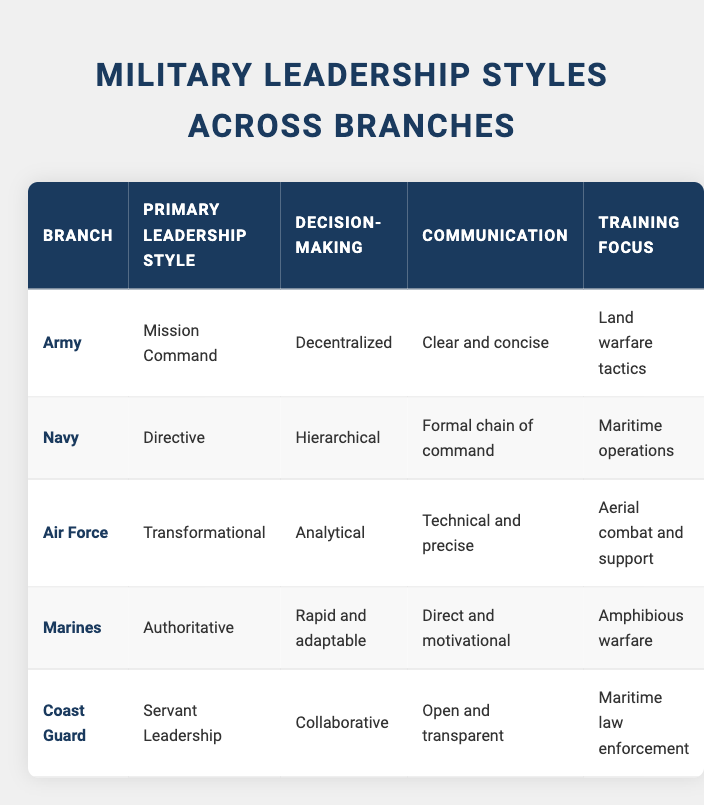What is the primary leadership style of the Marines? The table lists the primary leadership style of the Marines in the corresponding row. It shows that the Marines adopt an "Authoritative" leadership style.
Answer: Authoritative Which branch has a training focus on maritime law enforcement? By reviewing the table, we can identify that the Coast Guard is focused on "Maritime law enforcement" in their training. This is found in the row associated with the Coast Guard.
Answer: Coast Guard What type of decision-making does the Navy utilize? The Navy's decision-making style is detailed in its corresponding row in the table, which indicates it is "Hierarchical." This directly addresses the question about their approach to decision-making.
Answer: Hierarchical Is the Army’s primary communication style clear and concise? Checking the table for the Army's communication style confirms that it is described as "Clear and concise." This indicates that the statement is true.
Answer: Yes What is the difference between the decision-making styles of the Air Force and Coast Guard? The Air Force practices "Analytical" decision-making, while the Coast Guard employs "Collaborative." The difference lies in that the Air Force relies on analysis while the Coast Guard seeks teamwork in decision-making.
Answer: Analytical vs. Collaborative Which branches engage in decentralized decision-making? The Army is noted for its "Decentralized" decision-making style, while the Marines are recognized for their "Rapid and adaptable" approach. By filtering through the table, we find that these two branches emphasize a less centralized form of decision-making.
Answer: Army and Marines How many branches primarily use a directive leadership style? The table shows that only the Navy has a "Directive" leadership style. This can be deduced by checking each row for the respective leadership styles listed. Therefore, the answer is one branch.
Answer: One Which branch has the most distinct communication style compared to others? The table indicates that the Coast Guard uses "Open and transparent" communication, which stands out compared to others that emphasize clear, formal, technical, or motivational styles. This distinctiveness signifies a more inclusive communication approach.
Answer: Coast Guard Among the branches, which focuses on training for aerial combat and support? The Air Force is the branch identified in the table with a training focus on "Aerial combat and support." By locating this information in the table's respective row, we can confirm the focus clearly.
Answer: Air Force 